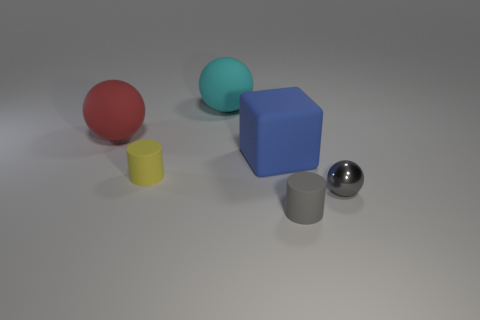Is the number of tiny gray rubber cylinders in front of the tiny yellow rubber cylinder greater than the number of things to the left of the large cyan ball?
Your answer should be very brief. No. The yellow matte object has what size?
Give a very brief answer. Small. There is a large thing right of the large cyan sphere; what shape is it?
Your answer should be compact. Cube. Is the big red matte object the same shape as the large cyan object?
Keep it short and to the point. Yes. Is the number of large blue objects to the right of the tiny yellow object the same as the number of blue cubes?
Ensure brevity in your answer.  Yes. What is the shape of the large blue rubber object?
Your response must be concise. Cube. Is there anything else that is the same color as the metallic thing?
Provide a succinct answer. Yes. There is a cyan object behind the red sphere; does it have the same size as the cylinder to the right of the large cyan object?
Offer a very short reply. No. What shape is the small object on the right side of the small gray object that is in front of the metallic object?
Offer a very short reply. Sphere. Do the gray metal thing and the rubber cylinder that is in front of the tiny yellow matte cylinder have the same size?
Give a very brief answer. Yes. 